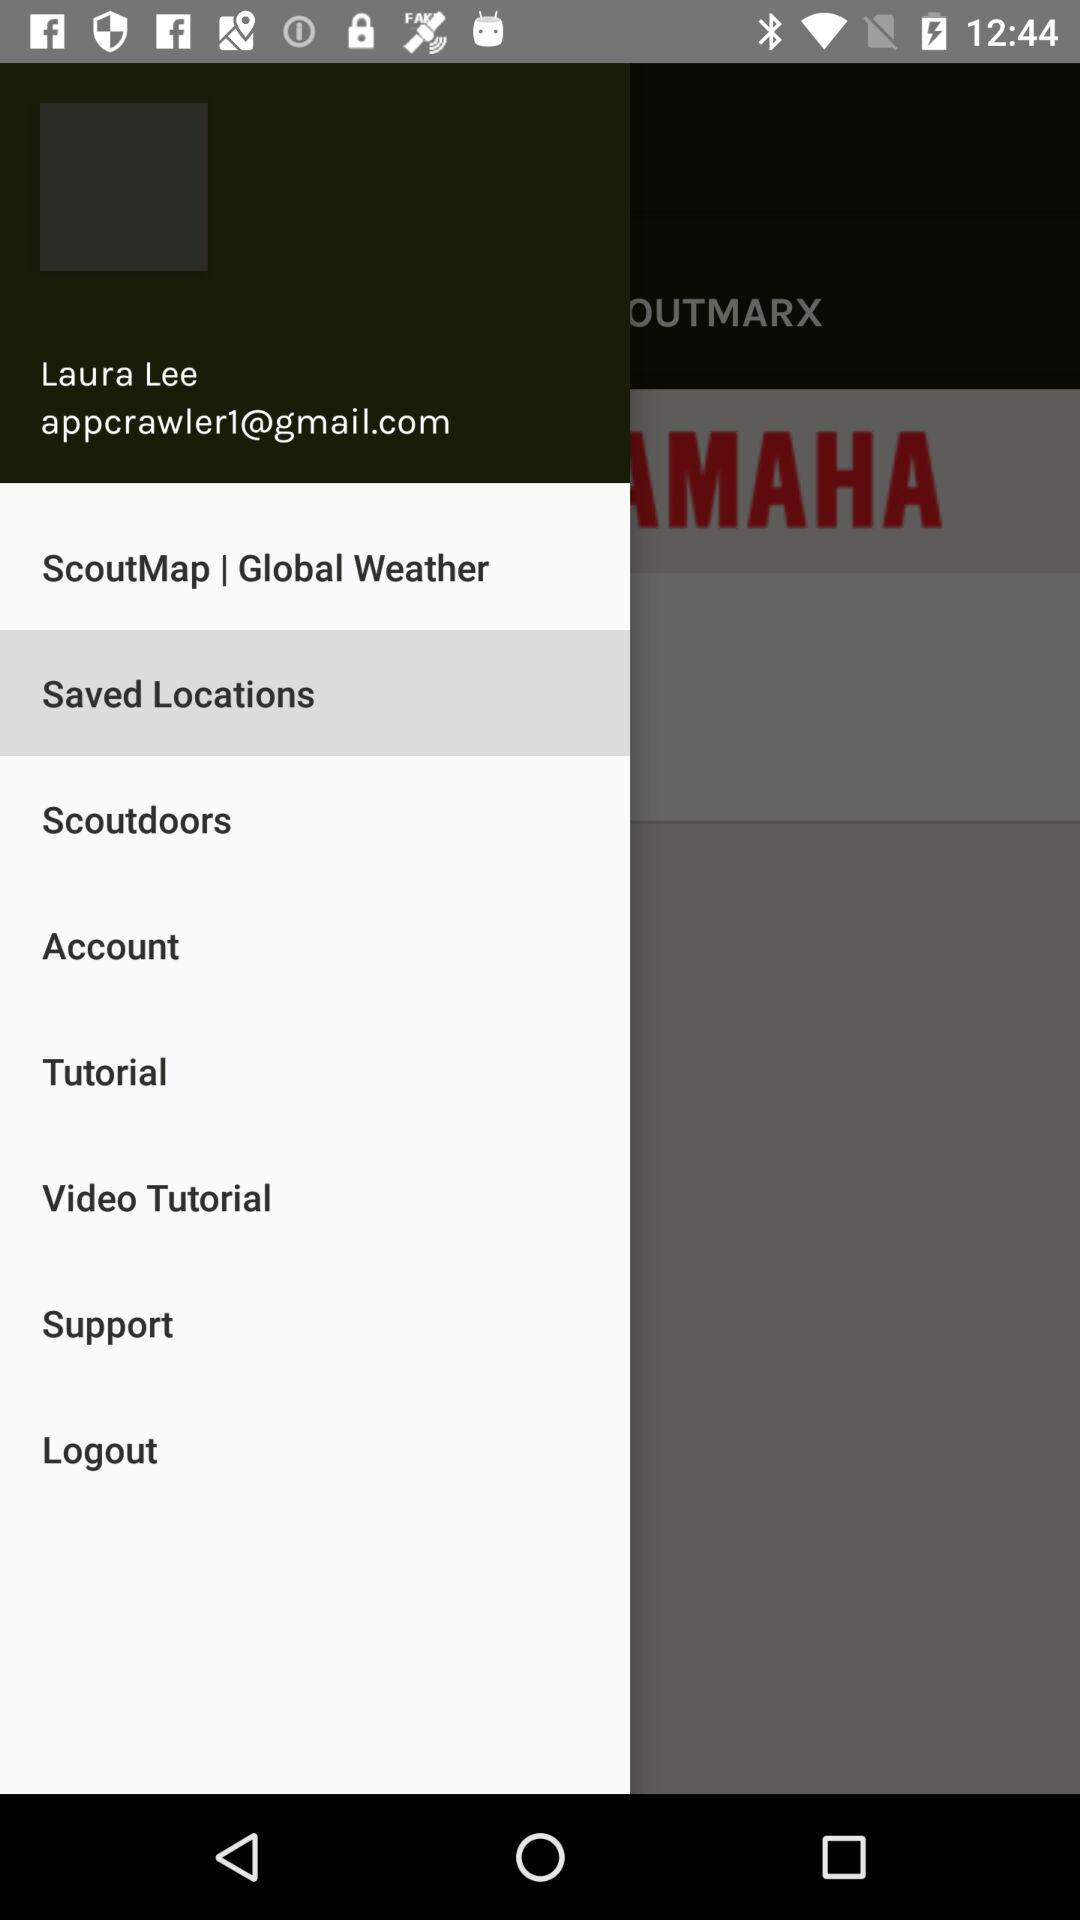Which item is selected? The selected item is "Saved Locations". 